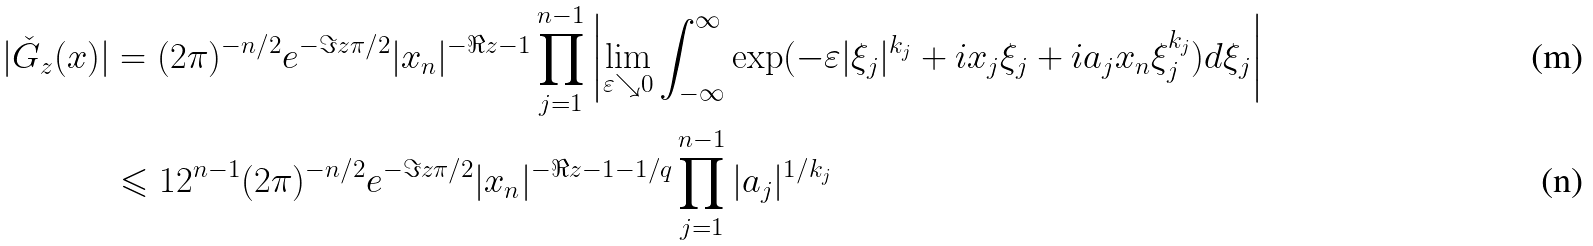<formula> <loc_0><loc_0><loc_500><loc_500>| \check { G } _ { z } ( x ) | & = ( 2 \pi ) ^ { - n / 2 } e ^ { - \Im z \pi / 2 } | x _ { n } | ^ { - \Re z - 1 } \prod _ { j = 1 } ^ { n - 1 } \left | \lim _ { \varepsilon \searrow 0 } \int _ { - \infty } ^ { \infty } \exp ( - \varepsilon | \xi _ { j } | ^ { k _ { j } } + i x _ { j } \xi _ { j } + i a _ { j } x _ { n } \xi _ { j } ^ { k _ { j } } ) d \xi _ { j } \right | \\ & \leqslant 1 2 ^ { n - 1 } ( 2 \pi ) ^ { - n / 2 } e ^ { - \Im z \pi / 2 } | x _ { n } | ^ { - \Re z - 1 - 1 / q } \prod _ { j = 1 } ^ { n - 1 } | a _ { j } | ^ { 1 / k _ { j } }</formula> 